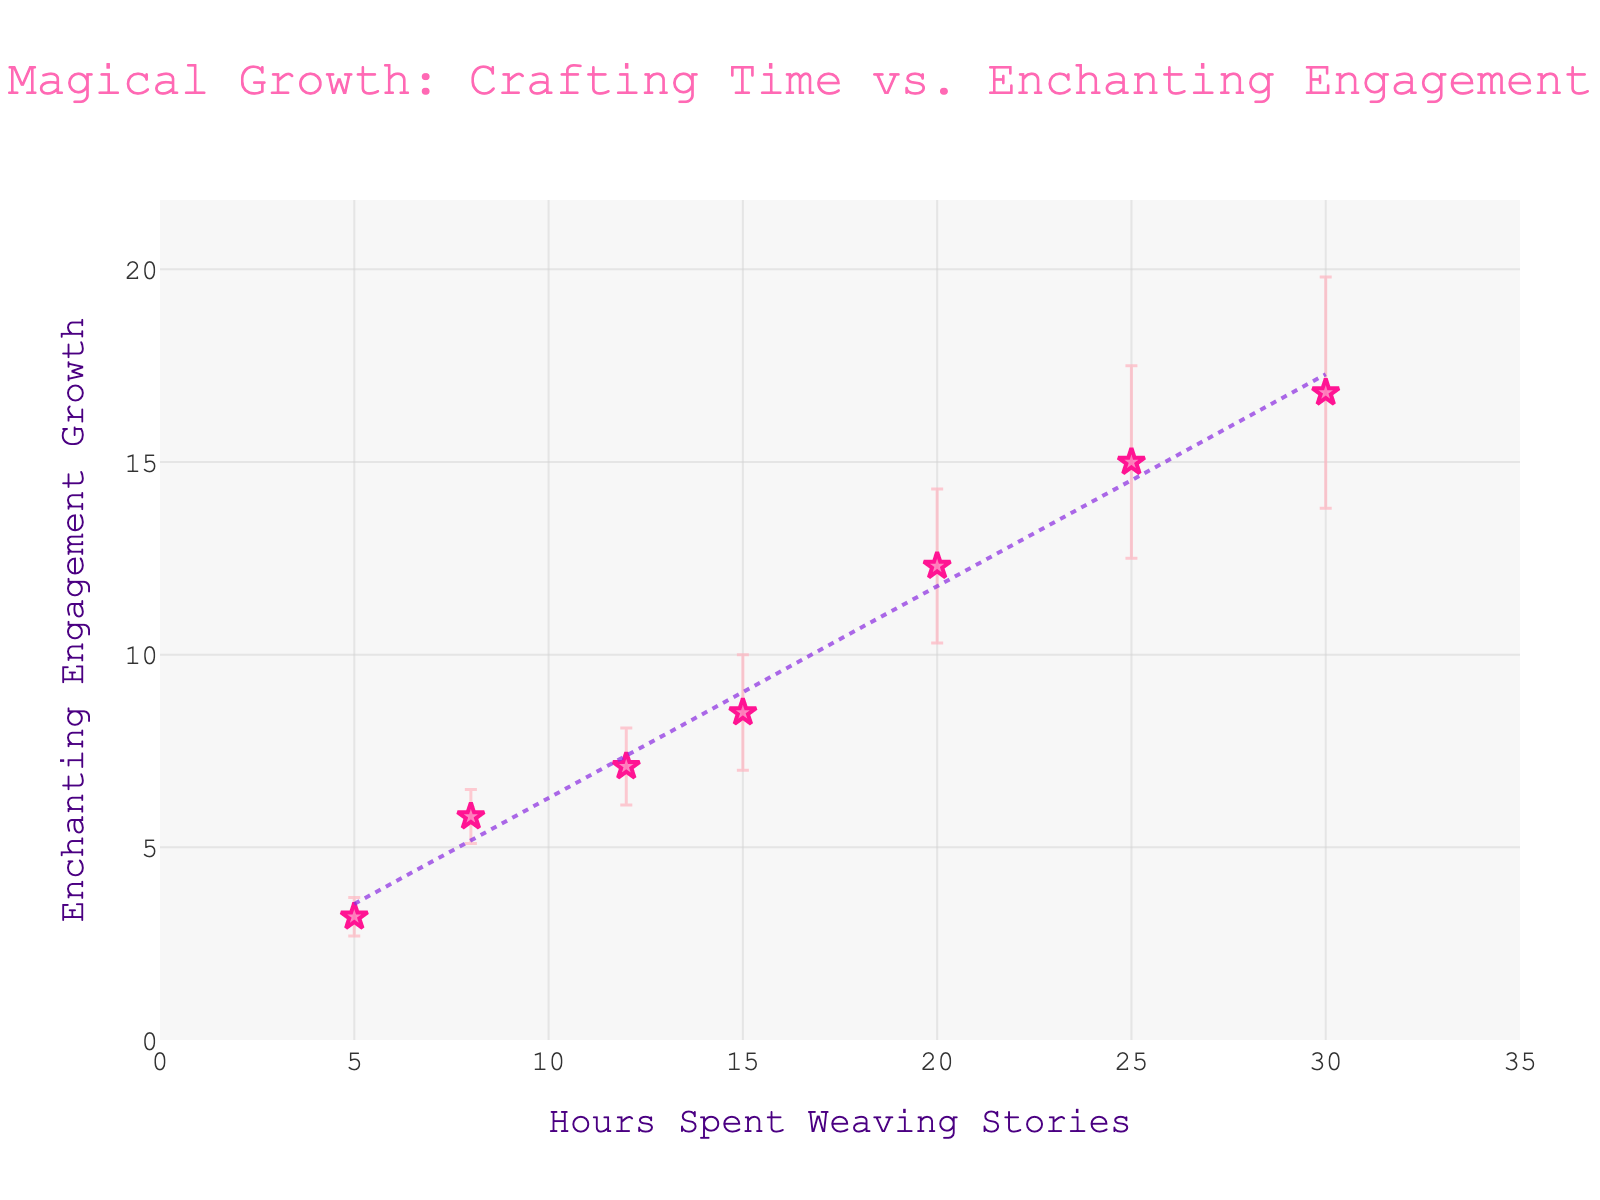How many data points are there in the plot? By counting all the markers (stars) in the plot, you can see that there are 7 points total.
Answer: 7 What is the title of the plot? Referring to the top of the plot, the title is "Magical Growth: Crafting Time vs. Enchanting Engagement".
Answer: Magical Growth: Crafting Time vs. Enchanting Engagement How many hours are spent at the point where engagement growth is approximately 8.5? Looking at the y-axis for the engagement growth value of approximately 8.5 and tracing horizontally to the corresponding x-axis value, 15 hours are spent.
Answer: 15 What is the uncertainty for the data point where hours spent is 20? For the marker at 20 hours on the x-axis, you see that the uncertainty bar extends above and below by ±2.0 in engagement growth units.
Answer: 2.0 Which data point has the highest engagement growth? By observing the y-axis and locating the highest point with respect to engagement growth, the data point at 30 hours with 16.8 engagement growth holds the highest value.
Answer: 30 hours What is the difference in engagement growth between points at 8 hours and 12 hours spent? At 8 hours, engagement growth is 5.8. At 12 hours, it is 7.1. The difference is calculated as 7.1 - 5.8 = 1.3.
Answer: 1.3 Between the hours spent of 5 and 25, which has a larger uncertainty in engagement growth? Comparing the uncertainty bars, the uncertainty at 5 hours is 0.5, while at 25 hours, it is 2.5. Thus, 25 hours has a larger uncertainty.
Answer: 25 Does the trendline indicate a positive or negative relationship between hours spent and engagement growth? The dotted trendline slopes upwards as it moves from left to right, indicating a positive relationship between hours spent and engagement growth.
Answer: Positive What is the approximate engagement growth when 10 hours are spent? Interpolating between the nearby data points of 8 hours (5.8) and 12 hours (7.1), and using the trendline, the engagement growth at 10 hours is approximately halfway between, around 6.45.
Answer: 6.45 How wide are the error bars for the data point corresponding to 15 hours spent? The error bars for the 15 hours data point span from 8.5 - 1.5 to 8.5 + 1.5, making them ±1.5 units wide.
Answer: ±1.5 